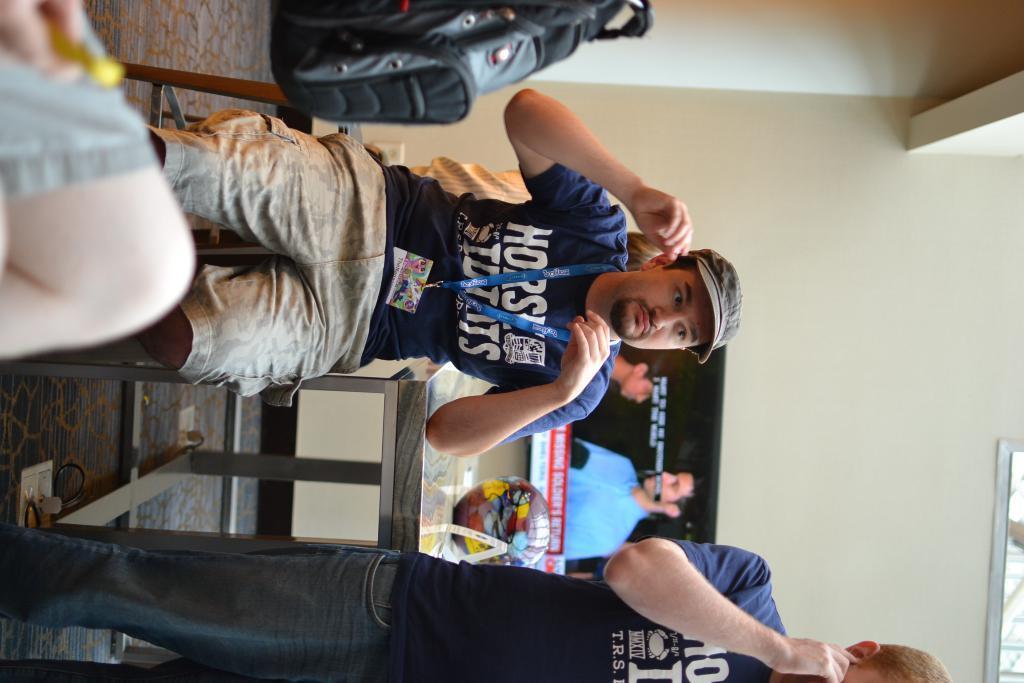Please provide a concise description of this image. On the right side of the image there is a person standing on the floor. On the left side of the image there are people sitting on the chairs. Behind them there is a table. On top of it there is a ball. In the background of the image there is a TV. There is a photo frame attached to the wall. 